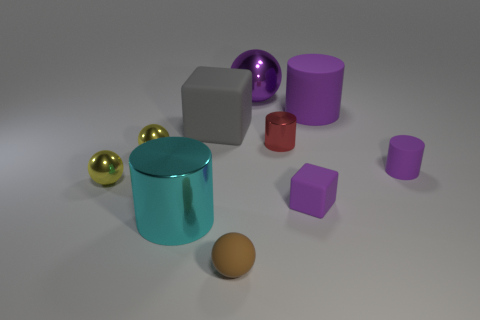Do the tiny cube and the shiny object that is behind the large purple rubber object have the same color?
Your response must be concise. Yes. What is the color of the shiny cylinder behind the purple rubber cylinder that is to the right of the large rubber cylinder?
Offer a very short reply. Red. There is a block that is the same size as the brown rubber thing; what is its color?
Provide a succinct answer. Purple. Is there a big brown matte object that has the same shape as the purple metallic thing?
Offer a terse response. No. The brown thing has what shape?
Ensure brevity in your answer.  Sphere. Are there more tiny purple things that are right of the tiny rubber block than tiny purple cubes in front of the big cyan metal cylinder?
Offer a terse response. Yes. What number of other objects are the same size as the gray matte block?
Make the answer very short. 3. What is the material of the thing that is in front of the small block and left of the gray block?
Your response must be concise. Metal. There is a cyan object that is the same shape as the large purple rubber thing; what is its material?
Make the answer very short. Metal. How many cylinders are in front of the big purple matte thing that is in front of the ball behind the big matte cylinder?
Give a very brief answer. 3. 